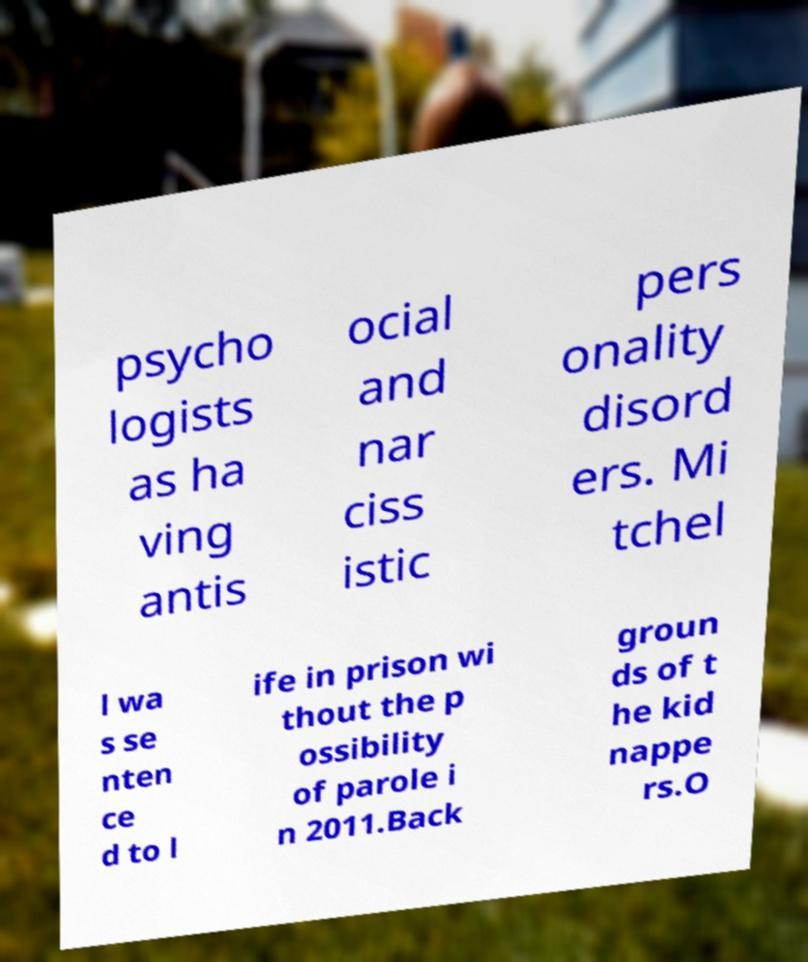Could you extract and type out the text from this image? psycho logists as ha ving antis ocial and nar ciss istic pers onality disord ers. Mi tchel l wa s se nten ce d to l ife in prison wi thout the p ossibility of parole i n 2011.Back groun ds of t he kid nappe rs.O 